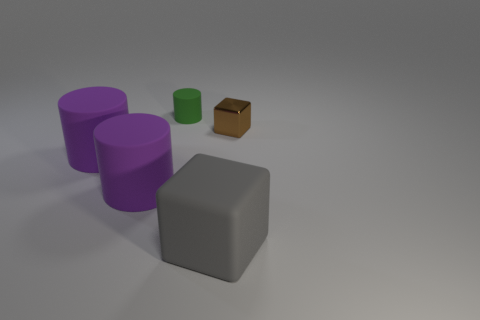Add 4 gray things. How many objects exist? 9 Subtract all blocks. How many objects are left? 3 Add 4 green cylinders. How many green cylinders are left? 5 Add 4 big gray shiny cylinders. How many big gray shiny cylinders exist? 4 Subtract 2 purple cylinders. How many objects are left? 3 Subtract all gray rubber objects. Subtract all brown matte balls. How many objects are left? 4 